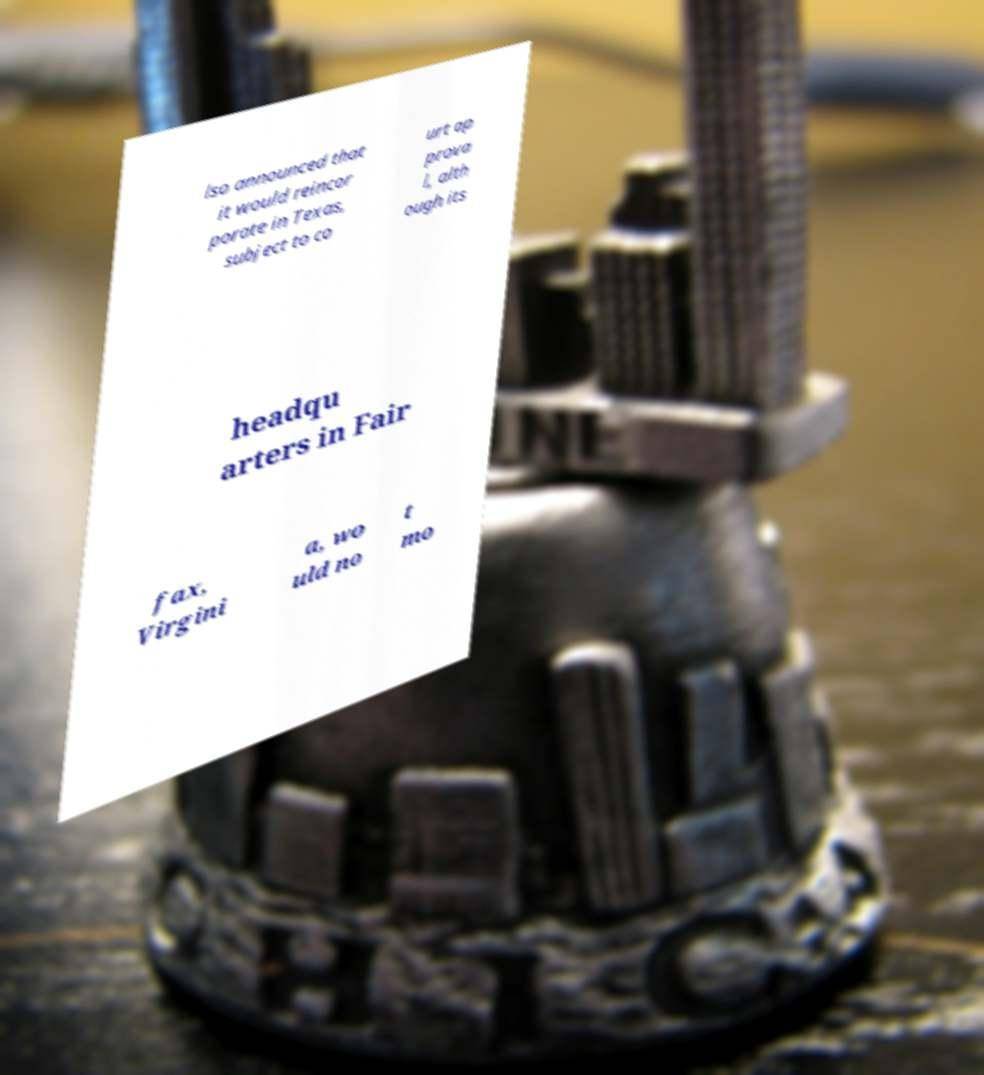Can you accurately transcribe the text from the provided image for me? lso announced that it would reincor porate in Texas, subject to co urt ap prova l, alth ough its headqu arters in Fair fax, Virgini a, wo uld no t mo 